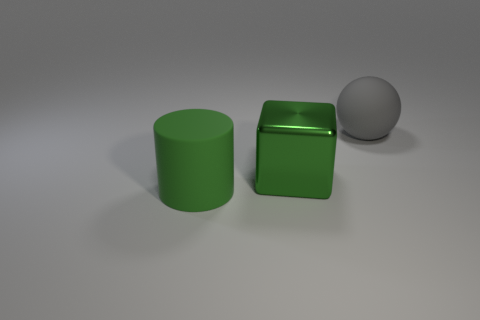What material is the gray ball that is behind the rubber thing in front of the big block made of? The gray ball appears to be made of a matte material, likely a plastic or a metallic composite, depending on the intended use in this context. Without additional context, such as touch or knowing the object's purpose, it's challenging to determine the specific material, but its muted sheen suggests it's not a reflective metal. 